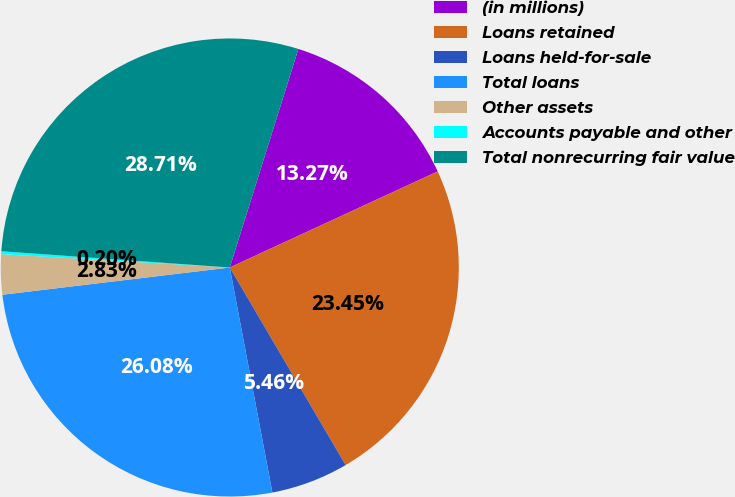Convert chart. <chart><loc_0><loc_0><loc_500><loc_500><pie_chart><fcel>(in millions)<fcel>Loans retained<fcel>Loans held-for-sale<fcel>Total loans<fcel>Other assets<fcel>Accounts payable and other<fcel>Total nonrecurring fair value<nl><fcel>13.27%<fcel>23.45%<fcel>5.46%<fcel>26.08%<fcel>2.83%<fcel>0.2%<fcel>28.71%<nl></chart> 